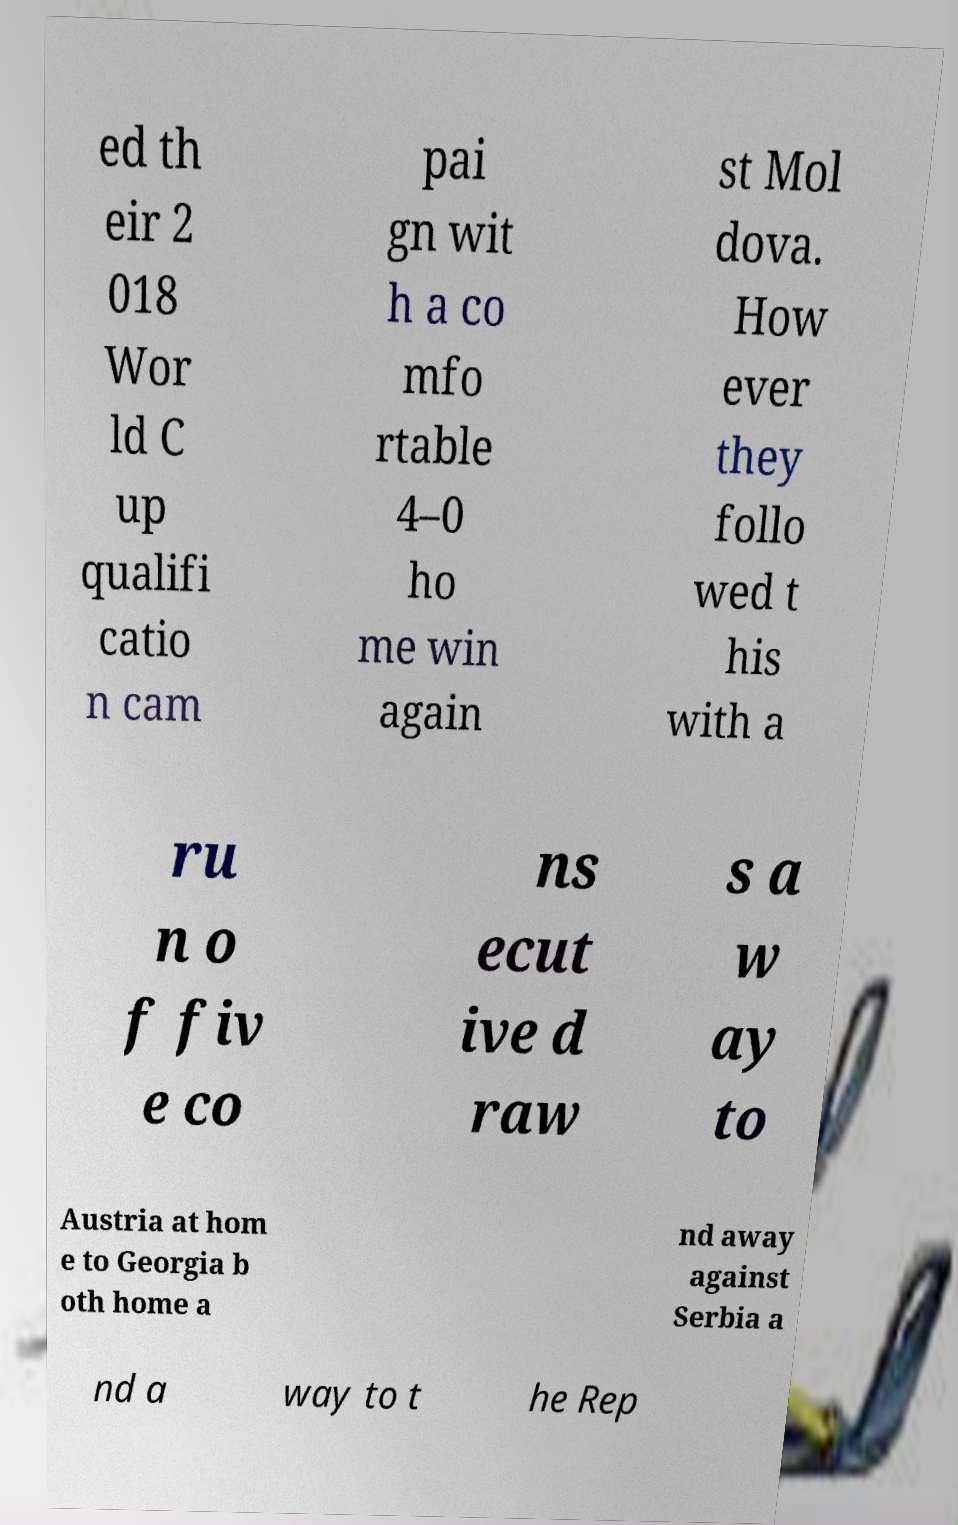For documentation purposes, I need the text within this image transcribed. Could you provide that? ed th eir 2 018 Wor ld C up qualifi catio n cam pai gn wit h a co mfo rtable 4–0 ho me win again st Mol dova. How ever they follo wed t his with a ru n o f fiv e co ns ecut ive d raw s a w ay to Austria at hom e to Georgia b oth home a nd away against Serbia a nd a way to t he Rep 